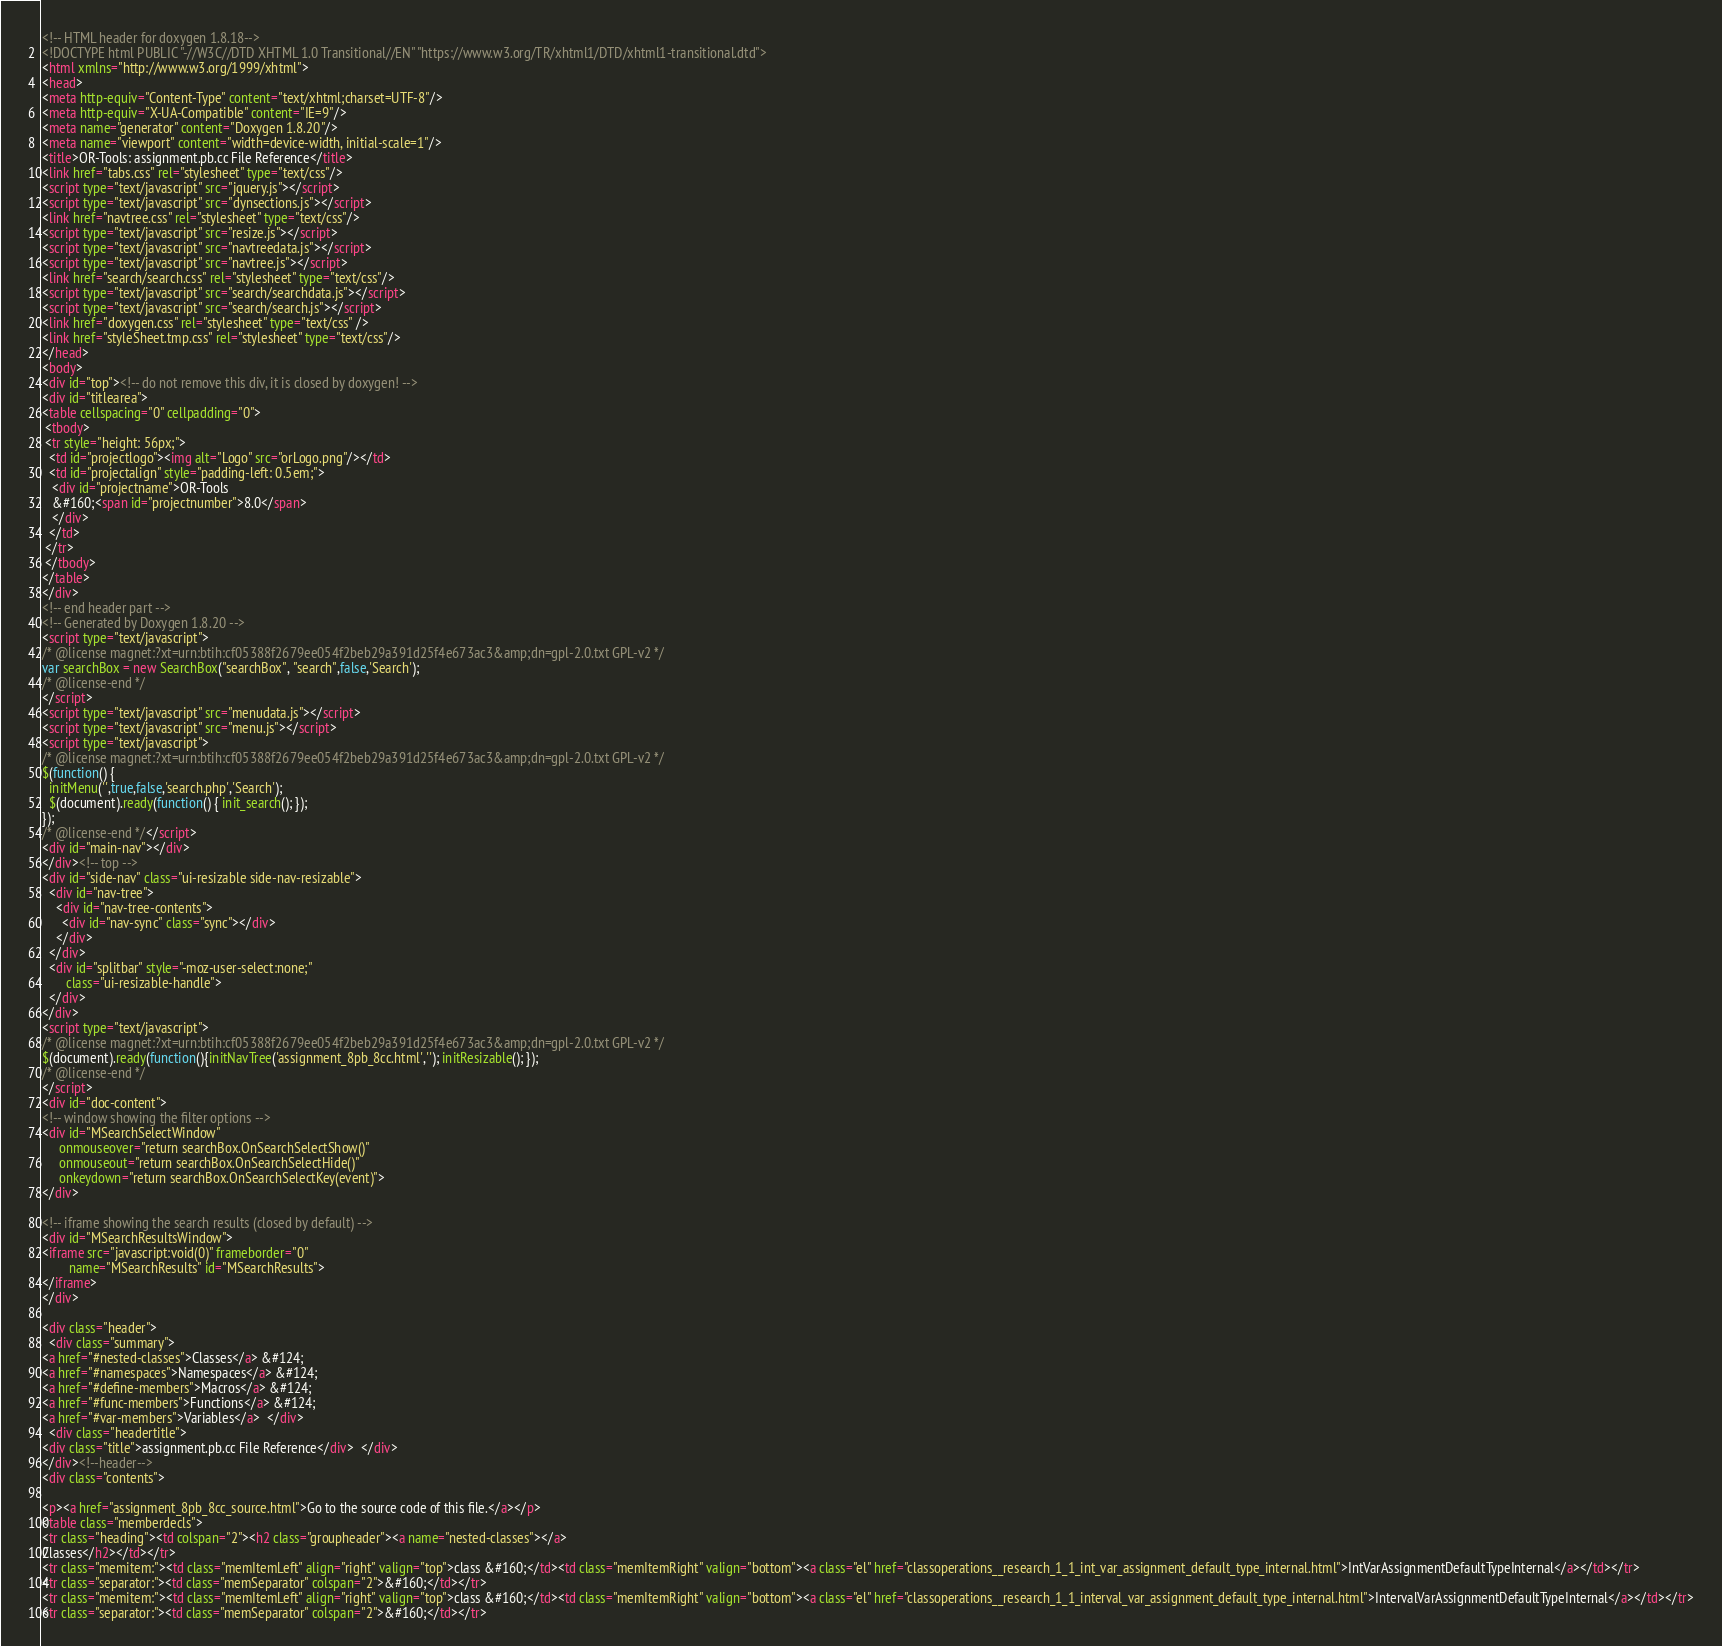<code> <loc_0><loc_0><loc_500><loc_500><_HTML_><!-- HTML header for doxygen 1.8.18-->
<!DOCTYPE html PUBLIC "-//W3C//DTD XHTML 1.0 Transitional//EN" "https://www.w3.org/TR/xhtml1/DTD/xhtml1-transitional.dtd">
<html xmlns="http://www.w3.org/1999/xhtml">
<head>
<meta http-equiv="Content-Type" content="text/xhtml;charset=UTF-8"/>
<meta http-equiv="X-UA-Compatible" content="IE=9"/>
<meta name="generator" content="Doxygen 1.8.20"/>
<meta name="viewport" content="width=device-width, initial-scale=1"/>
<title>OR-Tools: assignment.pb.cc File Reference</title>
<link href="tabs.css" rel="stylesheet" type="text/css"/>
<script type="text/javascript" src="jquery.js"></script>
<script type="text/javascript" src="dynsections.js"></script>
<link href="navtree.css" rel="stylesheet" type="text/css"/>
<script type="text/javascript" src="resize.js"></script>
<script type="text/javascript" src="navtreedata.js"></script>
<script type="text/javascript" src="navtree.js"></script>
<link href="search/search.css" rel="stylesheet" type="text/css"/>
<script type="text/javascript" src="search/searchdata.js"></script>
<script type="text/javascript" src="search/search.js"></script>
<link href="doxygen.css" rel="stylesheet" type="text/css" />
<link href="styleSheet.tmp.css" rel="stylesheet" type="text/css"/>
</head>
<body>
<div id="top"><!-- do not remove this div, it is closed by doxygen! -->
<div id="titlearea">
<table cellspacing="0" cellpadding="0">
 <tbody>
 <tr style="height: 56px;">
  <td id="projectlogo"><img alt="Logo" src="orLogo.png"/></td>
  <td id="projectalign" style="padding-left: 0.5em;">
   <div id="projectname">OR-Tools
   &#160;<span id="projectnumber">8.0</span>
   </div>
  </td>
 </tr>
 </tbody>
</table>
</div>
<!-- end header part -->
<!-- Generated by Doxygen 1.8.20 -->
<script type="text/javascript">
/* @license magnet:?xt=urn:btih:cf05388f2679ee054f2beb29a391d25f4e673ac3&amp;dn=gpl-2.0.txt GPL-v2 */
var searchBox = new SearchBox("searchBox", "search",false,'Search');
/* @license-end */
</script>
<script type="text/javascript" src="menudata.js"></script>
<script type="text/javascript" src="menu.js"></script>
<script type="text/javascript">
/* @license magnet:?xt=urn:btih:cf05388f2679ee054f2beb29a391d25f4e673ac3&amp;dn=gpl-2.0.txt GPL-v2 */
$(function() {
  initMenu('',true,false,'search.php','Search');
  $(document).ready(function() { init_search(); });
});
/* @license-end */</script>
<div id="main-nav"></div>
</div><!-- top -->
<div id="side-nav" class="ui-resizable side-nav-resizable">
  <div id="nav-tree">
    <div id="nav-tree-contents">
      <div id="nav-sync" class="sync"></div>
    </div>
  </div>
  <div id="splitbar" style="-moz-user-select:none;" 
       class="ui-resizable-handle">
  </div>
</div>
<script type="text/javascript">
/* @license magnet:?xt=urn:btih:cf05388f2679ee054f2beb29a391d25f4e673ac3&amp;dn=gpl-2.0.txt GPL-v2 */
$(document).ready(function(){initNavTree('assignment_8pb_8cc.html',''); initResizable(); });
/* @license-end */
</script>
<div id="doc-content">
<!-- window showing the filter options -->
<div id="MSearchSelectWindow"
     onmouseover="return searchBox.OnSearchSelectShow()"
     onmouseout="return searchBox.OnSearchSelectHide()"
     onkeydown="return searchBox.OnSearchSelectKey(event)">
</div>

<!-- iframe showing the search results (closed by default) -->
<div id="MSearchResultsWindow">
<iframe src="javascript:void(0)" frameborder="0" 
        name="MSearchResults" id="MSearchResults">
</iframe>
</div>

<div class="header">
  <div class="summary">
<a href="#nested-classes">Classes</a> &#124;
<a href="#namespaces">Namespaces</a> &#124;
<a href="#define-members">Macros</a> &#124;
<a href="#func-members">Functions</a> &#124;
<a href="#var-members">Variables</a>  </div>
  <div class="headertitle">
<div class="title">assignment.pb.cc File Reference</div>  </div>
</div><!--header-->
<div class="contents">

<p><a href="assignment_8pb_8cc_source.html">Go to the source code of this file.</a></p>
<table class="memberdecls">
<tr class="heading"><td colspan="2"><h2 class="groupheader"><a name="nested-classes"></a>
Classes</h2></td></tr>
<tr class="memitem:"><td class="memItemLeft" align="right" valign="top">class &#160;</td><td class="memItemRight" valign="bottom"><a class="el" href="classoperations__research_1_1_int_var_assignment_default_type_internal.html">IntVarAssignmentDefaultTypeInternal</a></td></tr>
<tr class="separator:"><td class="memSeparator" colspan="2">&#160;</td></tr>
<tr class="memitem:"><td class="memItemLeft" align="right" valign="top">class &#160;</td><td class="memItemRight" valign="bottom"><a class="el" href="classoperations__research_1_1_interval_var_assignment_default_type_internal.html">IntervalVarAssignmentDefaultTypeInternal</a></td></tr>
<tr class="separator:"><td class="memSeparator" colspan="2">&#160;</td></tr></code> 